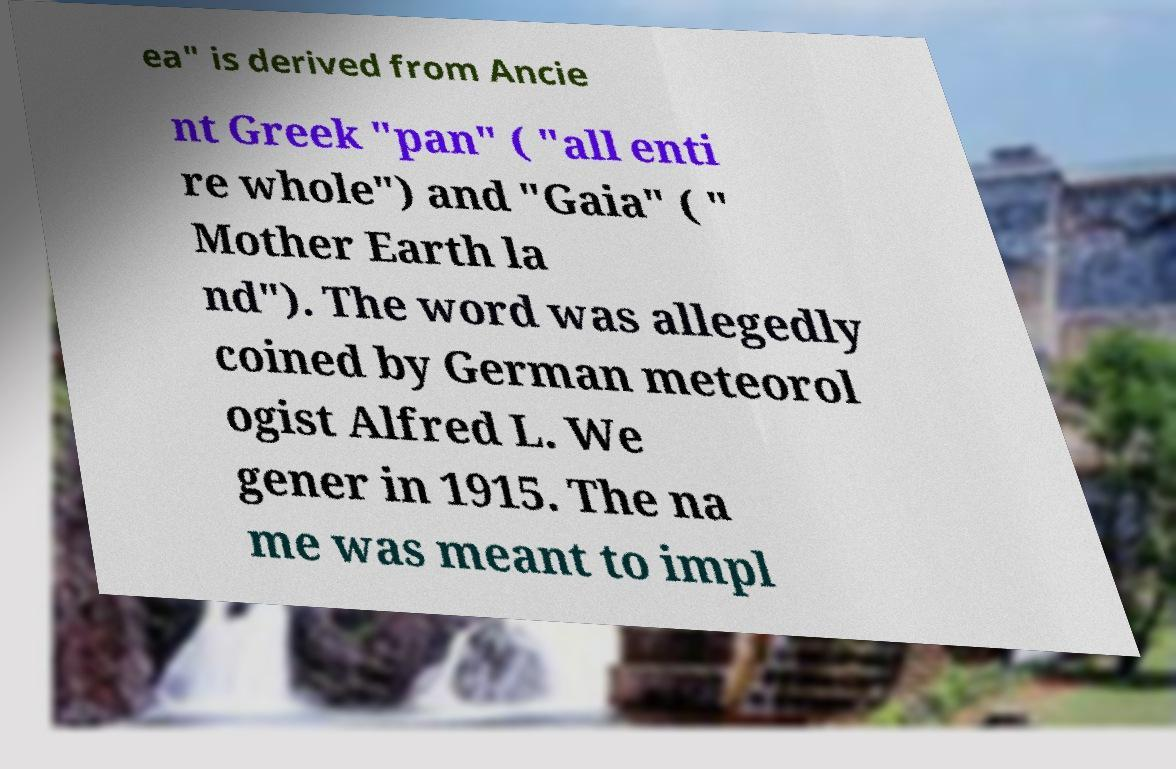What messages or text are displayed in this image? I need them in a readable, typed format. ea" is derived from Ancie nt Greek "pan" ( "all enti re whole") and "Gaia" ( " Mother Earth la nd"). The word was allegedly coined by German meteorol ogist Alfred L. We gener in 1915. The na me was meant to impl 